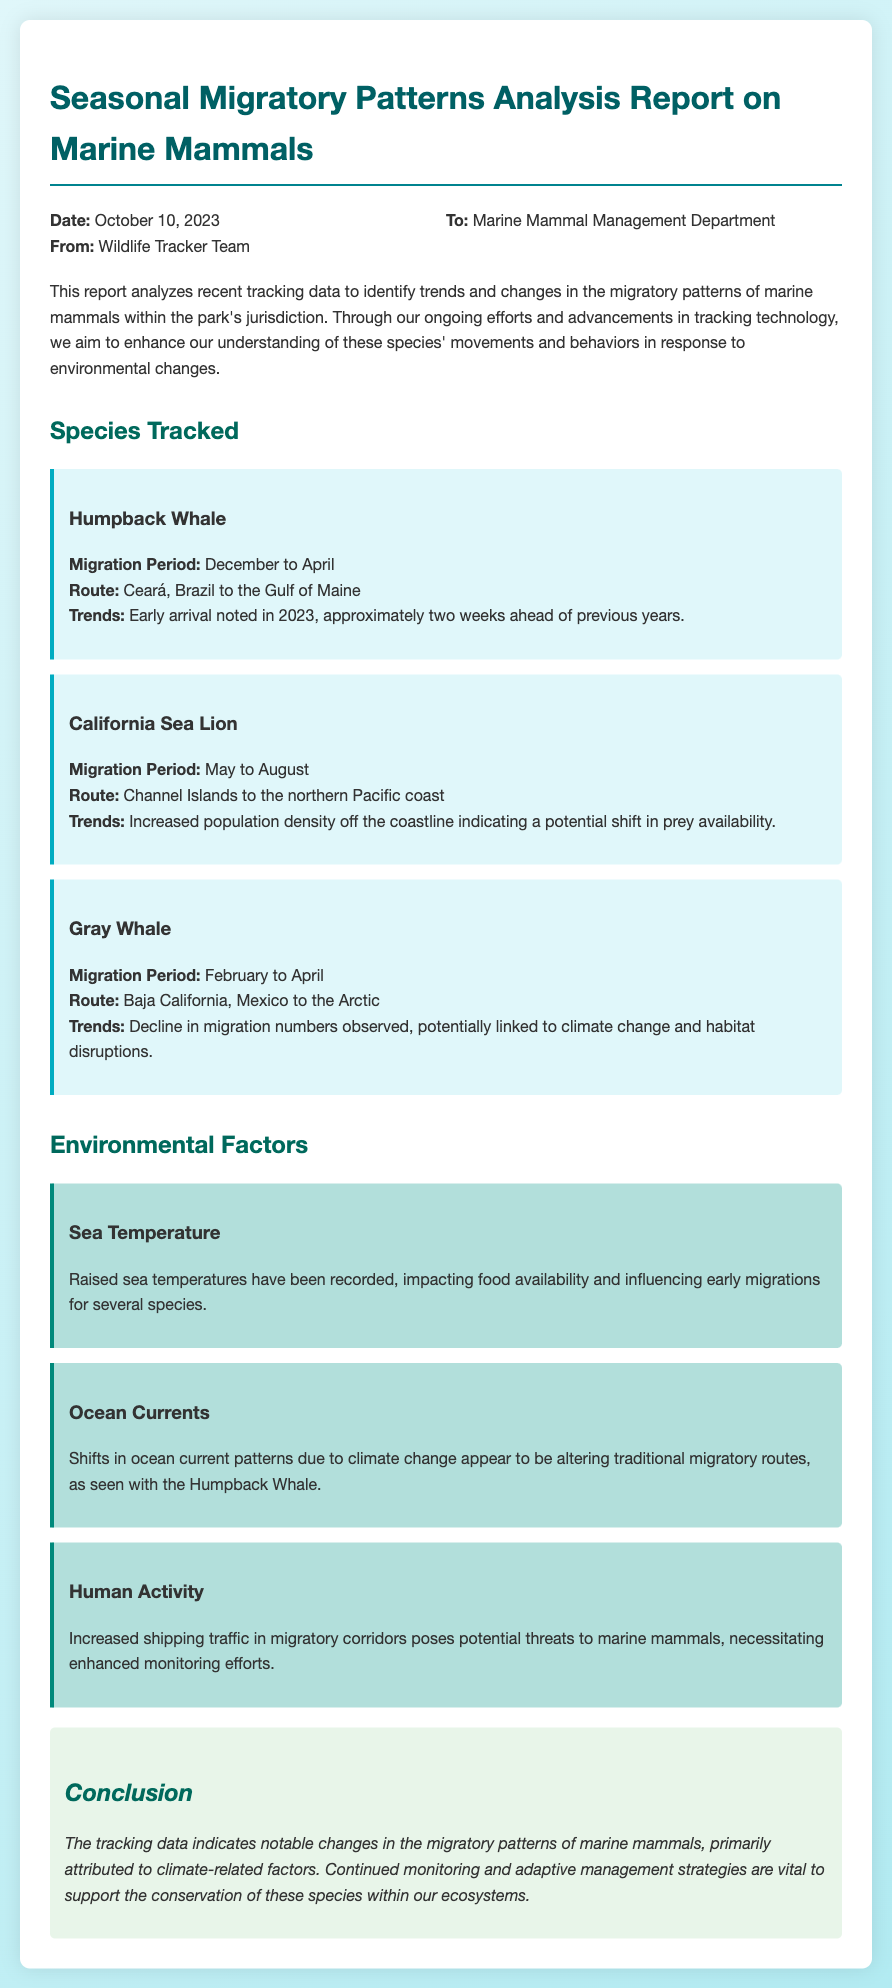What is the date of the report? The date of the report is mentioned in the header section as October 10, 2023.
Answer: October 10, 2023 Who is the report addressed to? The report specifies that it is addressed to the Marine Mammal Management Department.
Answer: Marine Mammal Management Department What species was noted for its early arrival in 2023? The document indicates that the Humpback Whale had an early arrival in 2023.
Answer: Humpback Whale What environmental factor is linked to increased shipping traffic? The document mentions that Human Activity poses potential threats to marine mammals.
Answer: Human Activity What was the migration period for the California Sea Lion? The migration period for the California Sea Lion is specified as May to August.
Answer: May to August What trend was observed for Gray Whales? The document states that a decline in migration numbers was observed for Gray Whales.
Answer: Decline in migration numbers What is the potential cause of changes in migratory patterns according to the conclusion? The conclusion states that changes in migratory patterns are attributed to climate-related factors.
Answer: Climate-related factors How have sea temperatures impacted migrations? The document explains that raised sea temperatures impact food availability and influence early migrations.
Answer: Affecting food availability 